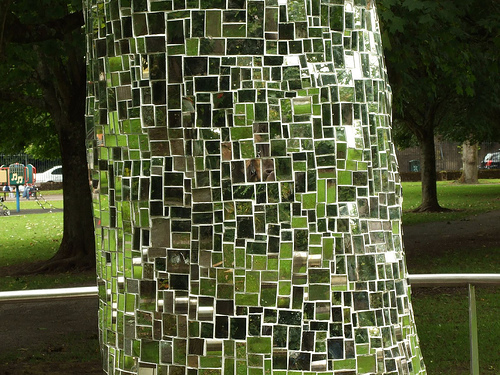<image>
Is the car in front of the tree? No. The car is not in front of the tree. The spatial positioning shows a different relationship between these objects. 